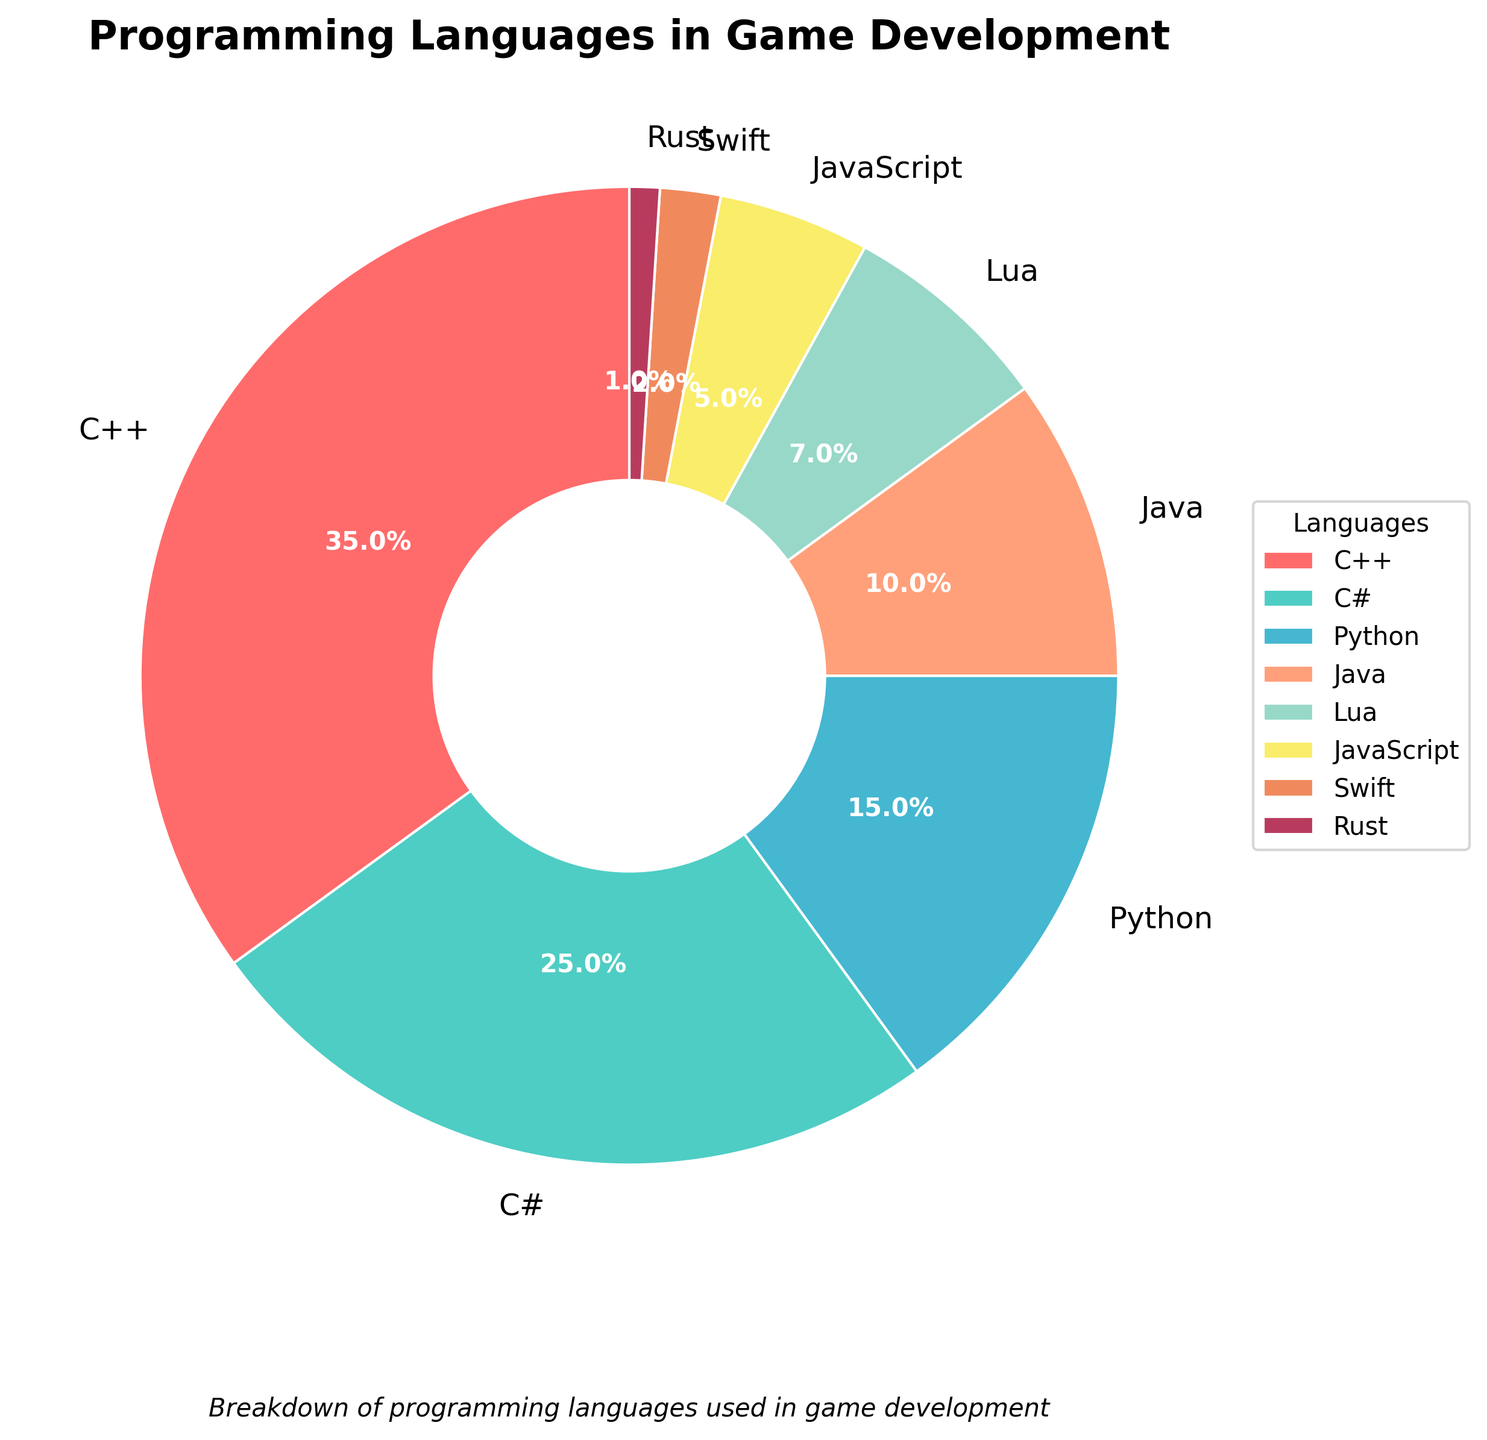What is the most commonly used programming language in game development according to the pie chart? The largest section of the pie chart represents the most commonly used language. According to the chart, C++ has the largest section, indicating it is the most used.
Answer: C++ What percentage of game developers use JavaScript and Rust combined? To find the combined percentage, add the percentage of game developers using JavaScript (5%) to the percentage using Rust (1%). So, 5% + 1% = 6%.
Answer: 6% Which language is more commonly used, Python or Java? Comparing the sizes of the sections for Python and Java, Python has 15% while Java has 10%. Python's section is larger, thus it is more commonly used.
Answer: Python What is the difference in the percentage of developers using C# and Lua? C# is used by 25% of developers, and Lua by 7%. Subtracting Lua's percentage from C#'s, we get 25% - 7% = 18%.
Answer: 18% Which three languages are the least used according to the chart, and what are their percentages? The languages with the smallest sections are Swift (2%), Rust (1%), and JavaScript (5%). These are the three least used languages.
Answer: Swift (2%), Rust (1%), JavaScript (5%) Is the combined usage of Java and Lua higher than the usage of C#? The percentage of developers using Java is 10% and Lua is 7%. Their combined usage is 10% + 7% = 17%. Comparing this to C#'s 25%, 17% is less than 25%.
Answer: No What is the visual attribute of the section representing Python in the pie chart? The section for Python in the chart is colored in a unique shade of blue, distinguishing it visually from the other sections.
Answer: Blue By how much does the usage of C++ exceed the combined usage of Swift and Rust? C++ is used by 35% of developers. Combining Swift and Rust, we get 2% + 1% = 3%. The difference is 35% - 3% = 32%.
Answer: 32% How many languages are used by more than 10% of developers? By examining the pie chart, the languages used by more than 10% are C++ (35%), C# (25%), and Python (15%), totaling three languages.
Answer: 3 